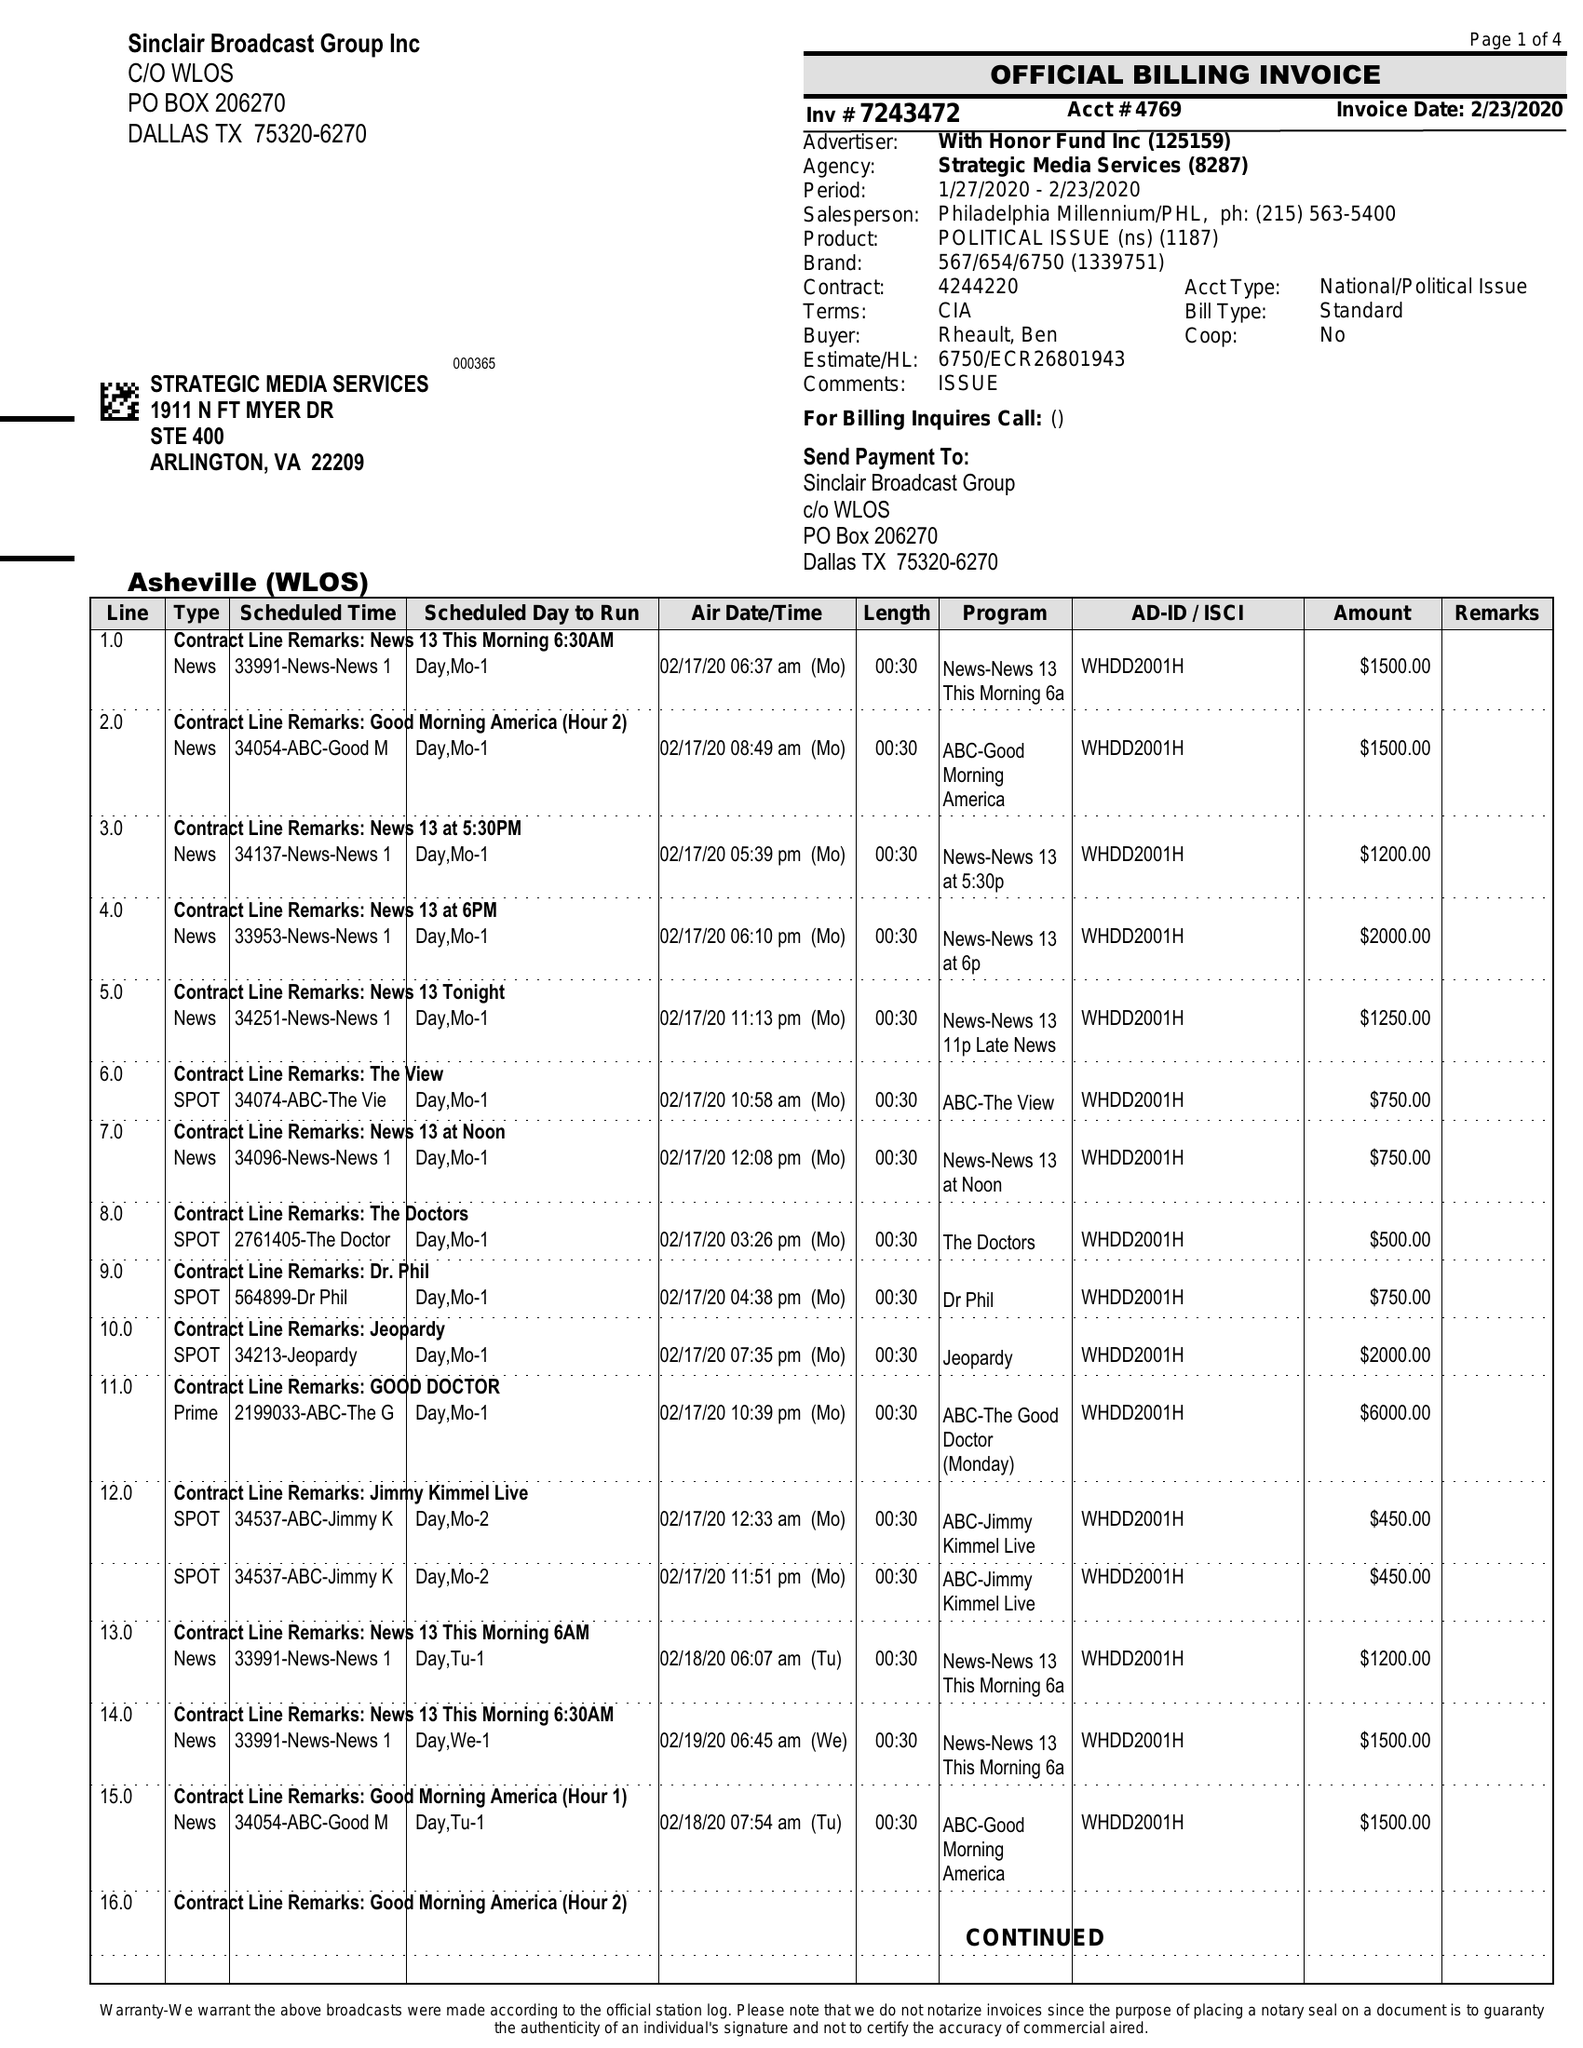What is the value for the flight_from?
Answer the question using a single word or phrase. 01/27/20 